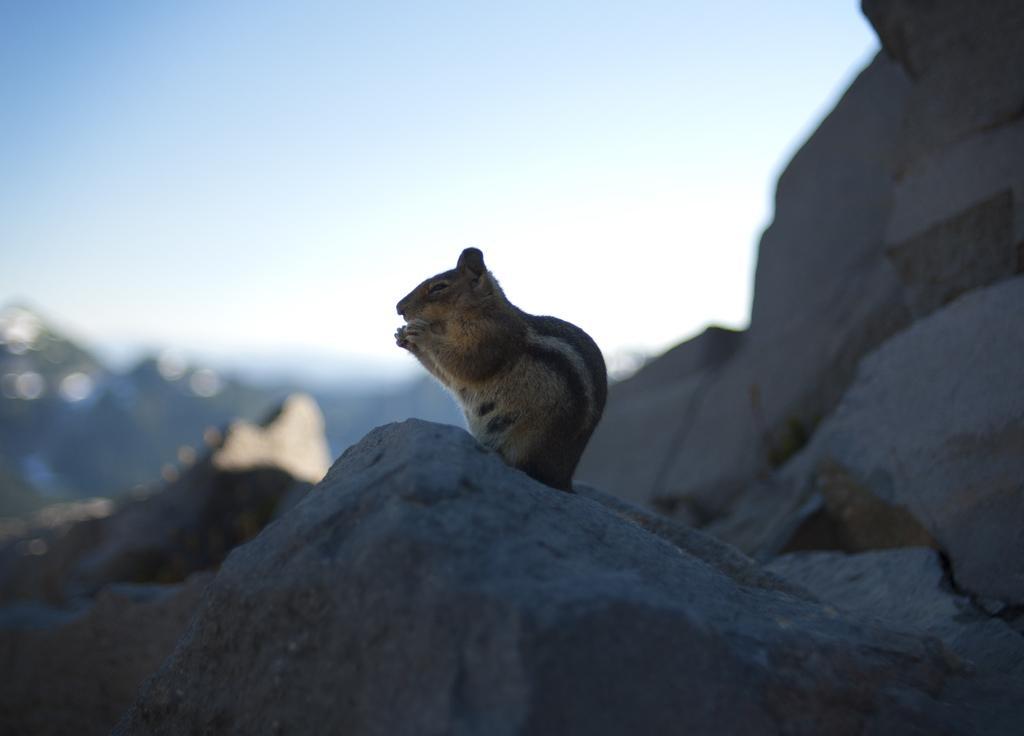In one or two sentences, can you explain what this image depicts? Here we can see a squirrel on the rock. There is a blur background and we can see sky. 